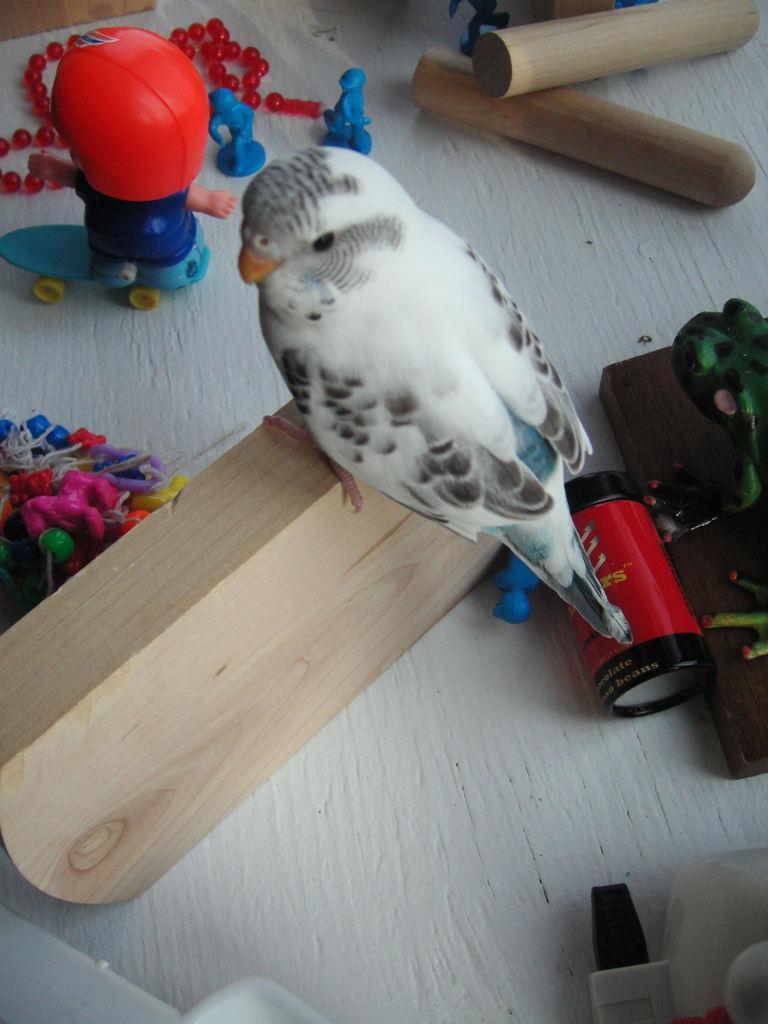What animal is present on a wooden piece in the image? There is a bird on a wooden piece in the image. What else can be seen in the image besides the bird? There are toys visible in the image. What is the color of the surface on which objects are placed in the image? The surface is white. What type of plane is the queen flying in the image? There is no plane or queen present in the image; it features a bird on a wooden piece and toys. What organization is responsible for the bird's presence in the image? There is no organization responsible for the bird's presence in the image; it is a natural occurrence. 